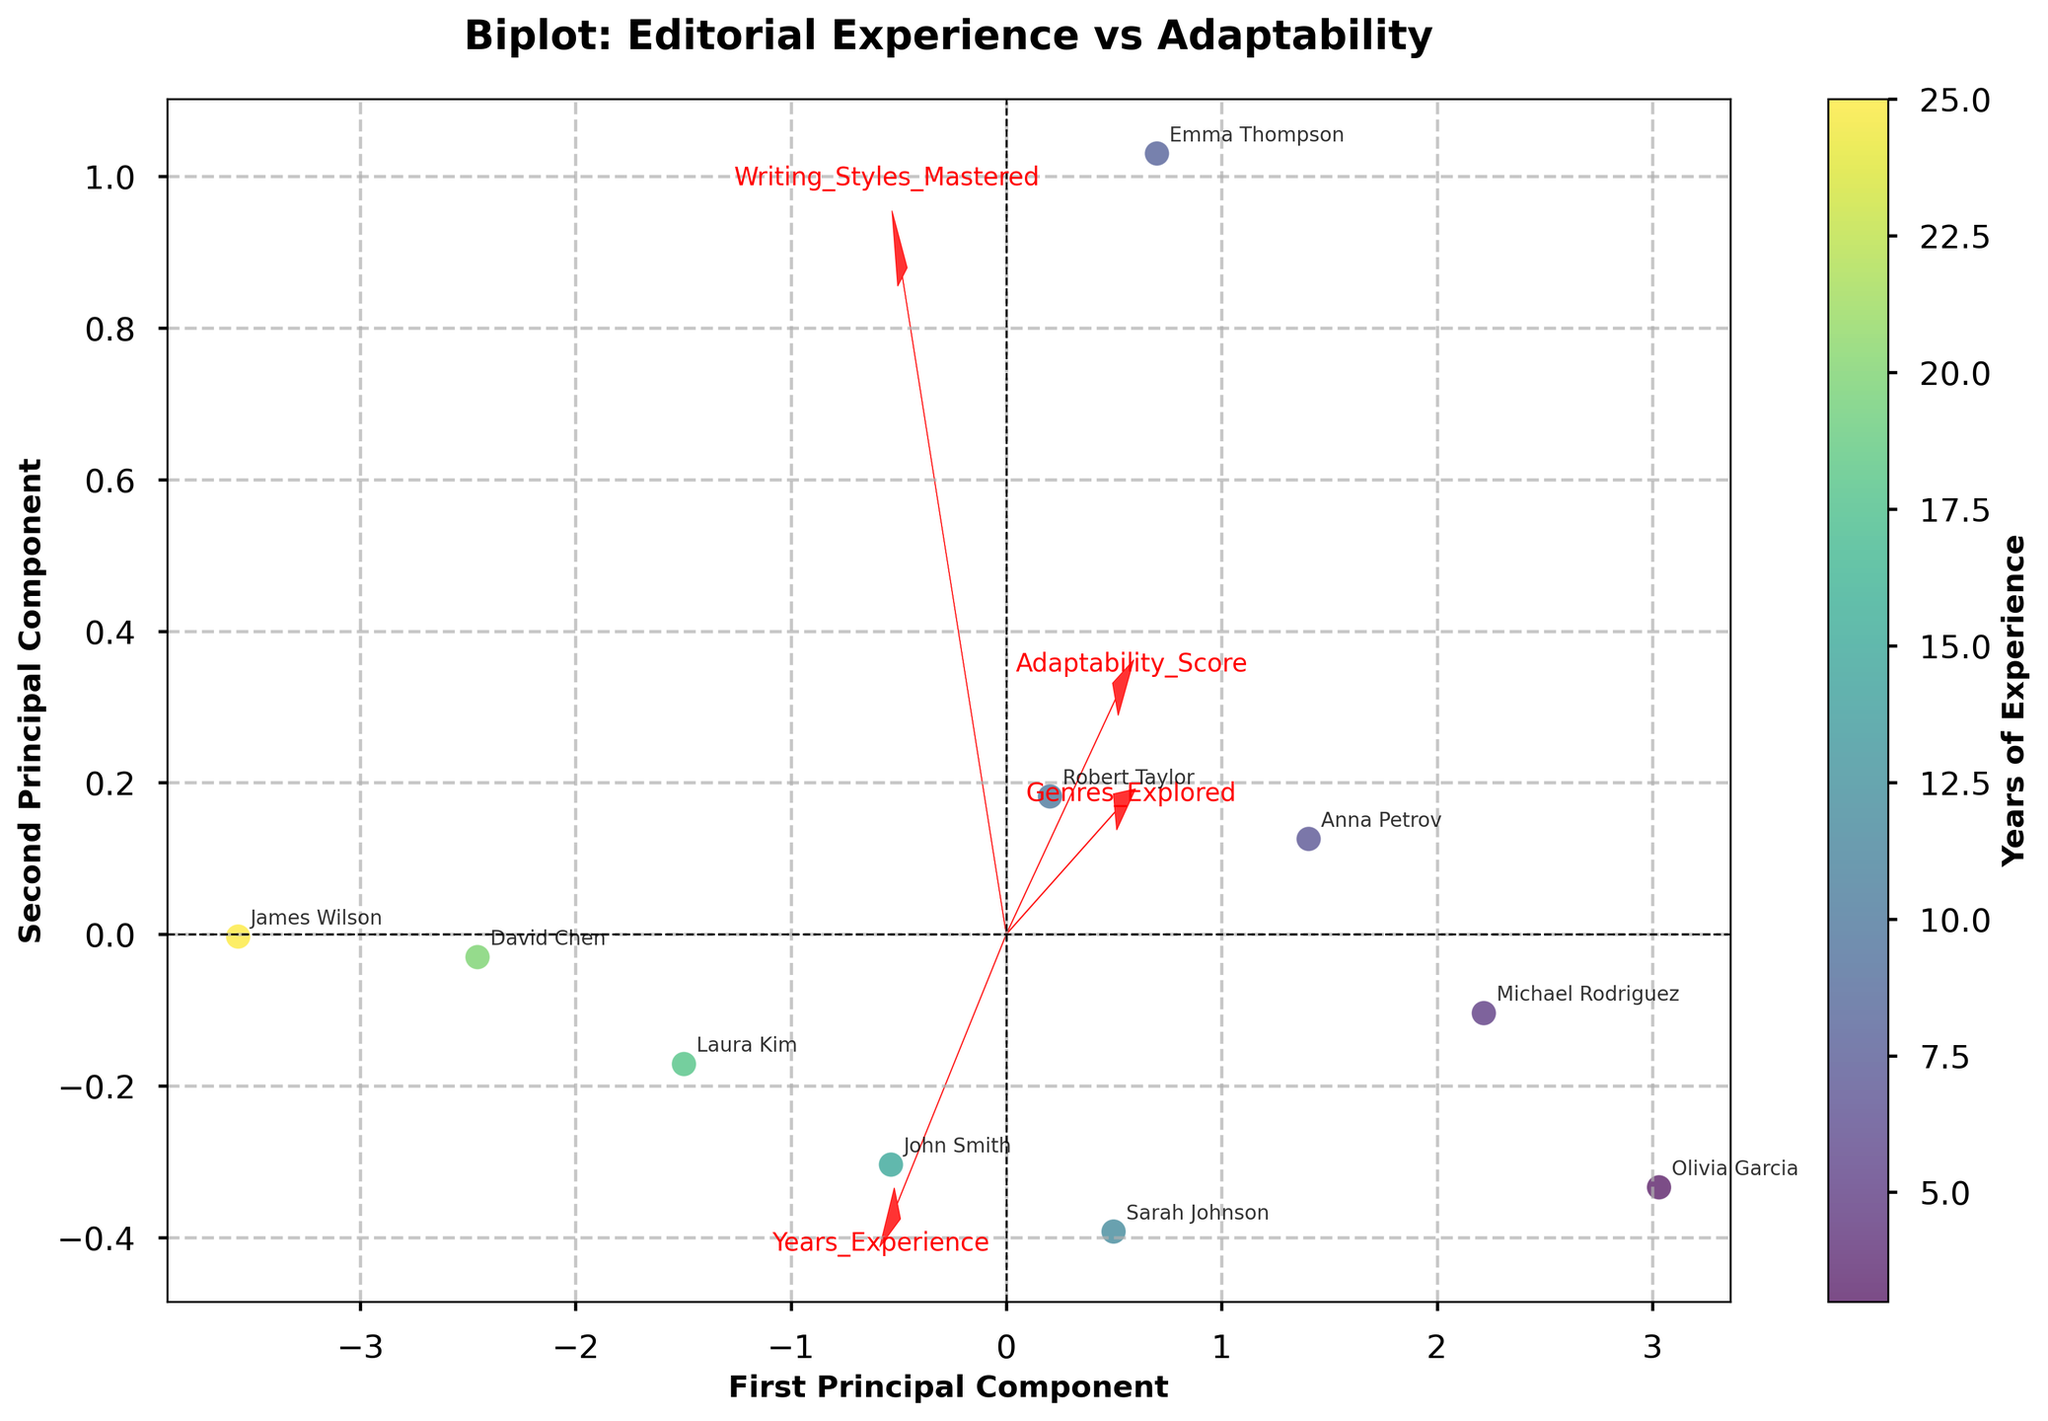How many feature vectors are displayed on the plot? The figure shows arrows representing feature vectors. Each arrow corresponds to one feature. To find the number of feature vectors, count the arrows.
Answer: 4 Which feature vector contributes the most to the first principal component? The contribution to the first principal component is indicated by the length and direction of the feature vector on the x-axis. Look for the arrow that extends the farthest along the x-axis.
Answer: Years of Experience Which editor has the highest adaptability score? The adaptability scores vary from the data provided. On the plot, the colors and labels can help identify which editor has the highest adaptability score. Look for the editor point positioned closely to the feature vector for Adaptability_Score.
Answer: Olivia Garcia How many editors have explored more than 5 genres? To find this, look at the data points' labels near the feature vector for Genres_Explored. Identify and count the labels corresponding to editors with scores above 5.
Answer: 6 Which feature vectors are most closely aligned? Look at the angles between the arrows representing different features. The feature vectors with the smallest angles between them are the most aligned.
Answer: Adaptability_Score and Genres_Explored Does the PCA plot show a clear separation between editors with high and low years of experience? Examine the distribution of the data points along the color gradient for Years of Experience. Check if there is a noticeable grouping of high and low values along any axis.
Answer: No Which editor is positioned closest to the origin on the plot? Look at the scatter plot and identify the data point (editor's label) that is nearest to the origin (0,0) of the plot.
Answer: Robert Taylor Are there any outliers or editors that do not fit the overall trend? Analyze the scatter of the data points and check for any that are significantly isolated from the majority.
Answer: James Wilson How does Adaptability_Score correlate with Years_Experience based on the plot? Determine the relative positioning of the two feature vectors (arrows). If they're in similar or opposite directions, this indicates correlation. Check how the data points cluster around these vectors.
Answer: Moderately positively Which editor is represented by a data point closest to the feature vector for Writing_Styles_Mastered? On the plot, identify which data point (editor label) is nearest to the direction of the Writing_Styles_Mastered feature vector (arrow).
Answer: James Wilson 